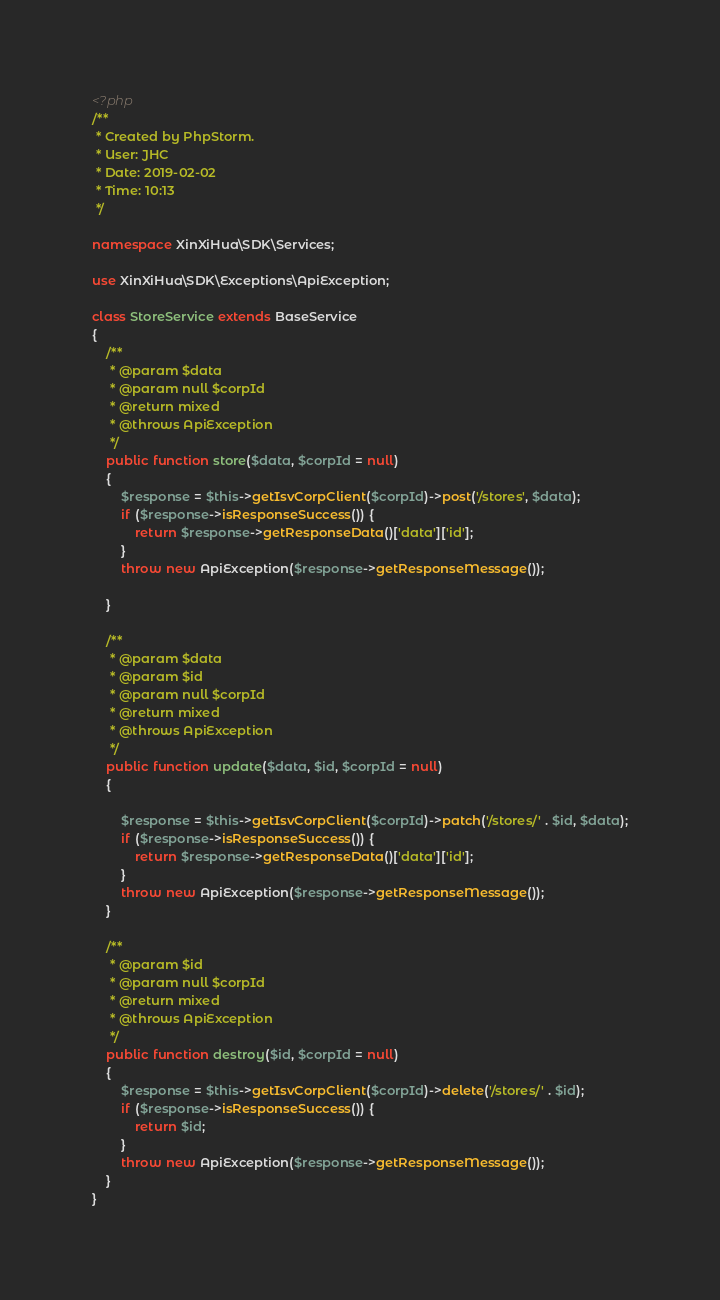<code> <loc_0><loc_0><loc_500><loc_500><_PHP_><?php
/**
 * Created by PhpStorm.
 * User: JHC
 * Date: 2019-02-02
 * Time: 10:13
 */

namespace XinXiHua\SDK\Services;

use XinXiHua\SDK\Exceptions\ApiException;

class StoreService extends BaseService
{
    /**
     * @param $data
     * @param null $corpId
     * @return mixed
     * @throws ApiException
     */
    public function store($data, $corpId = null)
    {
        $response = $this->getIsvCorpClient($corpId)->post('/stores', $data);
        if ($response->isResponseSuccess()) {
            return $response->getResponseData()['data']['id'];
        }
        throw new ApiException($response->getResponseMessage());

    }

    /**
     * @param $data
     * @param $id
     * @param null $corpId
     * @return mixed
     * @throws ApiException
     */
    public function update($data, $id, $corpId = null)
    {

        $response = $this->getIsvCorpClient($corpId)->patch('/stores/' . $id, $data);
        if ($response->isResponseSuccess()) {
            return $response->getResponseData()['data']['id'];
        }
        throw new ApiException($response->getResponseMessage());
    }

    /**
     * @param $id
     * @param null $corpId
     * @return mixed
     * @throws ApiException
     */
    public function destroy($id, $corpId = null)
    {
        $response = $this->getIsvCorpClient($corpId)->delete('/stores/' . $id);
        if ($response->isResponseSuccess()) {
            return $id;
        }
        throw new ApiException($response->getResponseMessage());
    }
}</code> 